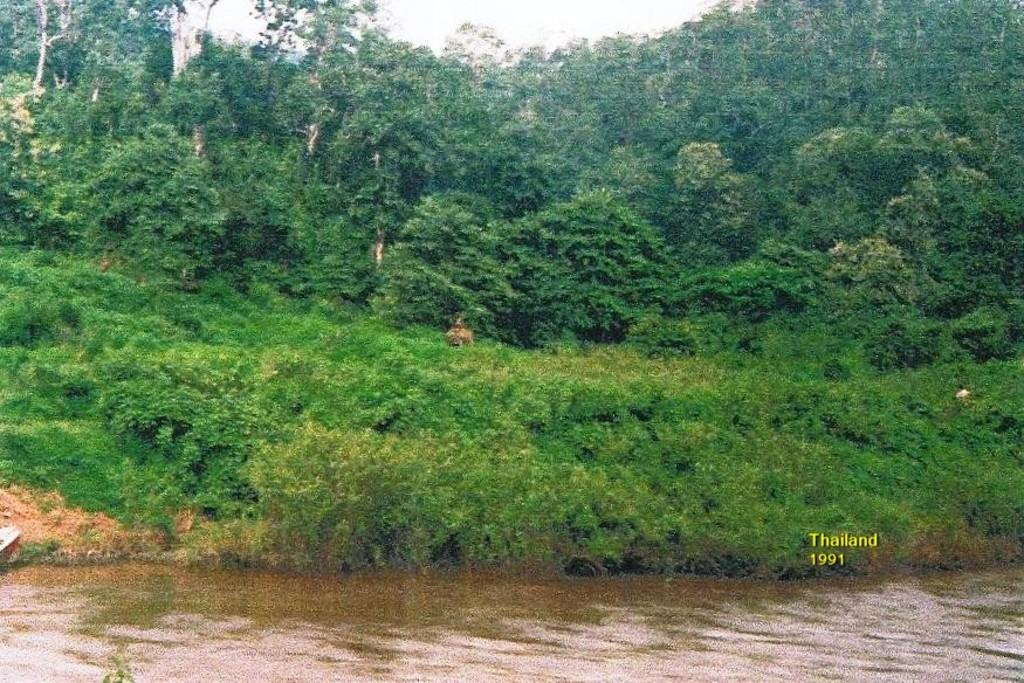What is at the bottom of the image? There is water at the bottom of the image. What can be seen behind the water? There are plants on the ground behind the water. What is visible in the background of the image? There are trees in the background of the image. Where is the text located in the image? The text is on the right side of the image. What type of anger can be seen on the faces of the plants in the image? There are no faces or emotions depicted on the plants in the image. What message of hope is conveyed by the text on the right side of the image? The content of the text cannot be determined from the image, so it is not possible to determine any message of hope. 